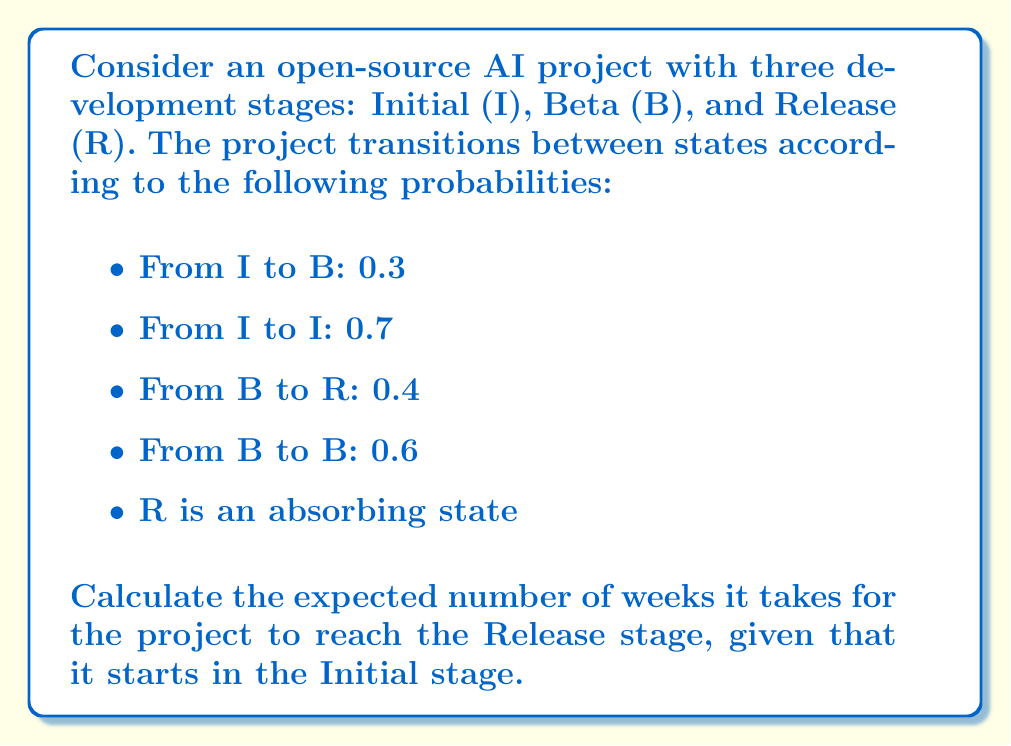Provide a solution to this math problem. Let's solve this problem using Markov chains and the fundamental matrix method:

1) First, we construct the transition matrix P:

   $$P = \begin{bmatrix}
   0.7 & 0.3 & 0 \\
   0 & 0.6 & 0.4 \\
   0 & 0 & 1
   \end{bmatrix}$$

2) We identify the transient states (I and B) and the absorbing state (R). Let Q be the submatrix of P containing only the transient states:

   $$Q = \begin{bmatrix}
   0.7 & 0.3 \\
   0 & 0.6
   \end{bmatrix}$$

3) Calculate the fundamental matrix N = (I - Q)^(-1):

   $$N = (I - Q)^{-1} = \begin{bmatrix}
   1 & 0 \\
   0 & 1
   \end{bmatrix} - \begin{bmatrix}
   0.7 & 0.3 \\
   0 & 0.6
   \end{bmatrix} = \begin{bmatrix}
   0.3 & -0.3 \\
   0 & 0.4
   \end{bmatrix}^{-1}$$

   $$N = \begin{bmatrix}
   3.33333 & 2.5 \\
   0 & 2.5
   \end{bmatrix}$$

4) The expected number of steps to absorption (Release stage) from each transient state is given by N1, where 1 is a column vector of ones:

   $$N1 = \begin{bmatrix}
   3.33333 & 2.5 \\
   0 & 2.5
   \end{bmatrix} \begin{bmatrix}
   1 \\
   1
   \end{bmatrix} = \begin{bmatrix}
   5.83333 \\
   2.5
   \end{bmatrix}$$

5) Since we start in the Initial state, we look at the first element of N1, which is approximately 5.83333.

Therefore, the expected number of weeks to reach the Release stage, starting from the Initial stage, is approximately 5.83333 weeks.
Answer: 5.83333 weeks 